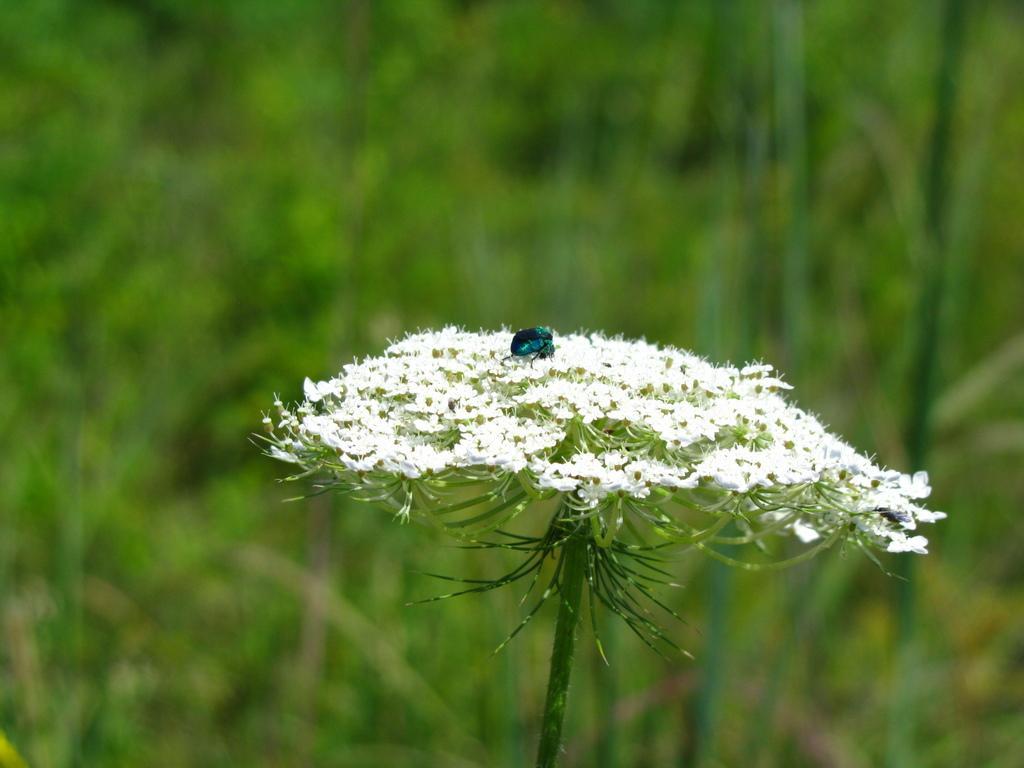Please provide a concise description of this image. In this picture, we can see some flowers on a plant and insect on it and the background is blurred. 